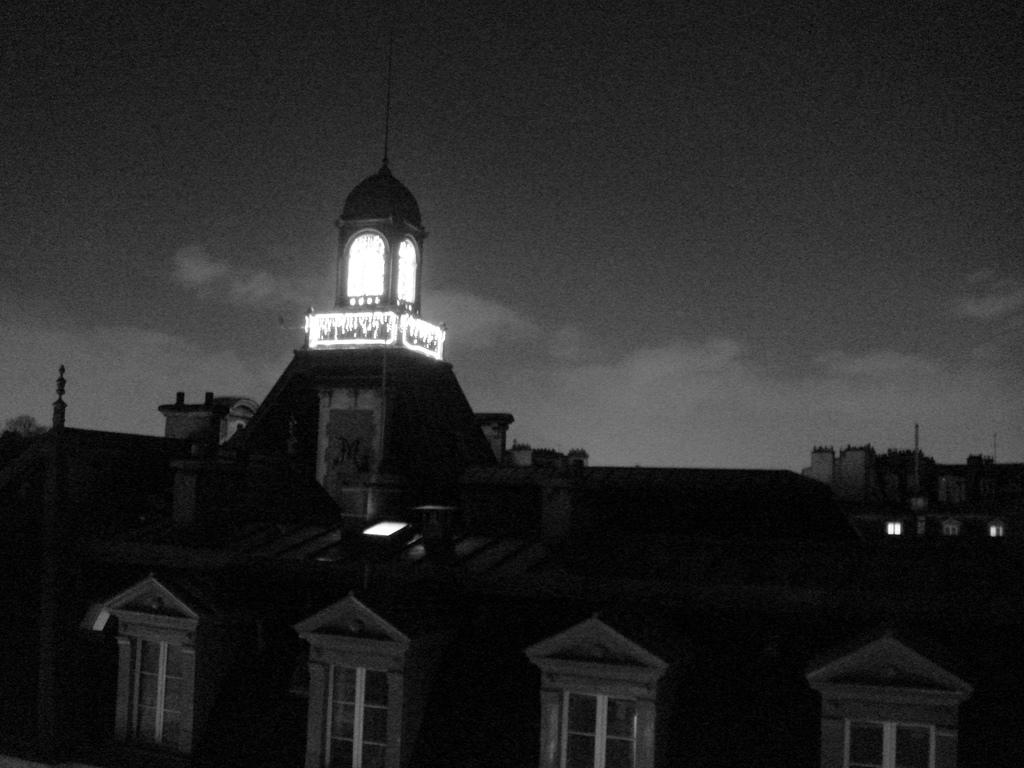What type of openings can be seen in the image? There are windows in the image. What type of structures are visible in the image? There are buildings in the image. What type of illumination is present in the image? There are lights in the image. What can be seen in the background of the image? The sky is visible in the background of the image. What type of cheese is being used to cover the clock in the image? There is no clock or cheese present in the image. What color is the lipstick on the person's lips in the image? There are no people or lips present in the image. 